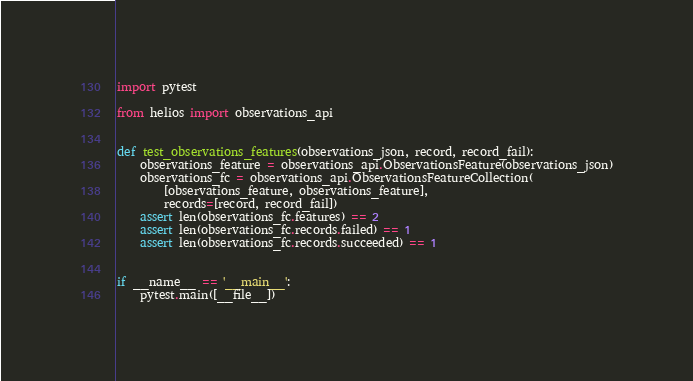<code> <loc_0><loc_0><loc_500><loc_500><_Python_>import pytest

from helios import observations_api


def test_observations_features(observations_json, record, record_fail):
    observations_feature = observations_api.ObservationsFeature(observations_json)
    observations_fc = observations_api.ObservationsFeatureCollection(
        [observations_feature, observations_feature],
        records=[record, record_fail])
    assert len(observations_fc.features) == 2
    assert len(observations_fc.records.failed) == 1
    assert len(observations_fc.records.succeeded) == 1


if __name__ == '__main__':
    pytest.main([__file__])
</code> 